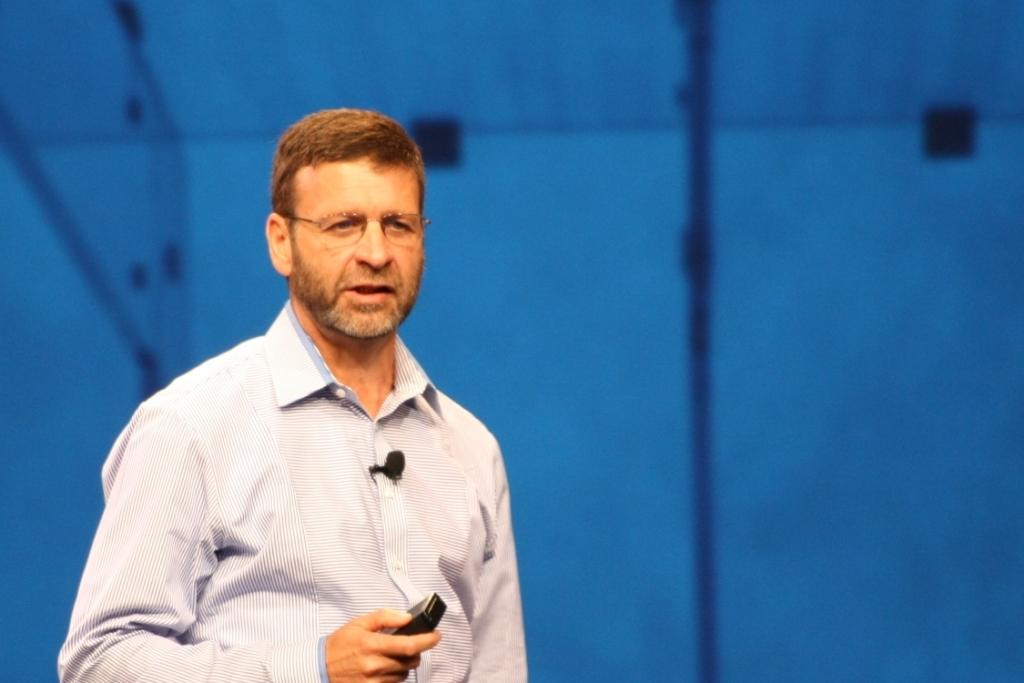What is the main subject of the picture? The main subject of the picture is a man. What is the man doing in the image? The man is standing in the picture. What object is the man holding in his hand? The man is holding a remote in his right hand. What can be seen in the background of the image? There is a blue surface in the backdrop of the image. What type of bottle is the man holding in his left hand? The man is not holding a bottle in his left hand; he is holding a remote in his right hand. Can you tell me how many sisters the man has in the image? There is no information about the man's sisters in the image. 